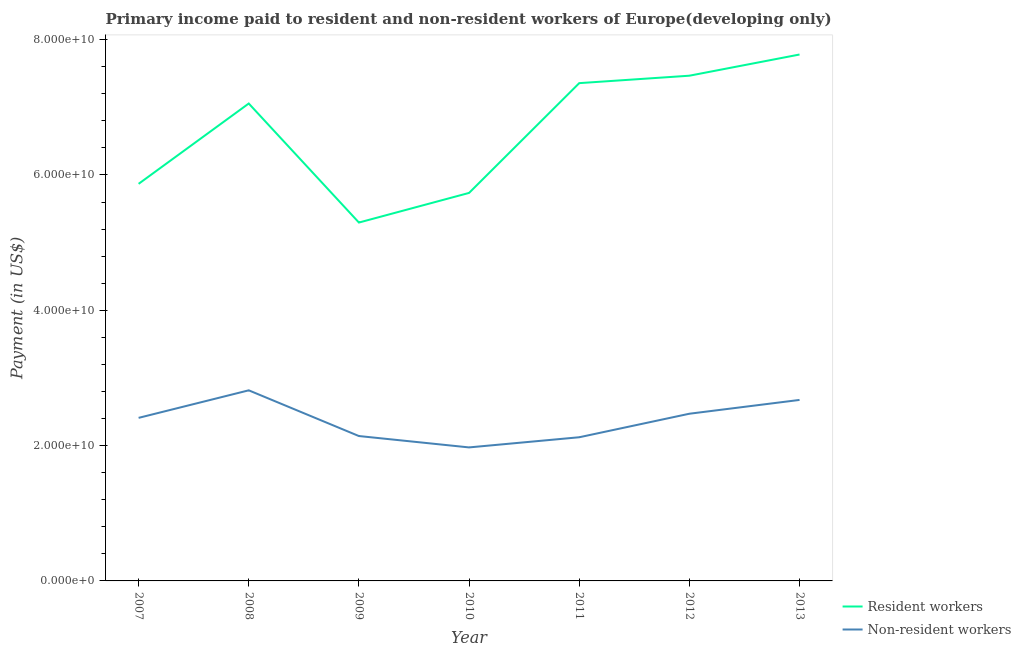How many different coloured lines are there?
Provide a succinct answer. 2. Is the number of lines equal to the number of legend labels?
Make the answer very short. Yes. What is the payment made to non-resident workers in 2007?
Offer a terse response. 2.41e+1. Across all years, what is the maximum payment made to resident workers?
Ensure brevity in your answer.  7.78e+1. Across all years, what is the minimum payment made to non-resident workers?
Your response must be concise. 1.97e+1. What is the total payment made to non-resident workers in the graph?
Keep it short and to the point. 1.66e+11. What is the difference between the payment made to resident workers in 2008 and that in 2010?
Offer a very short reply. 1.32e+1. What is the difference between the payment made to non-resident workers in 2011 and the payment made to resident workers in 2008?
Your answer should be very brief. -4.93e+1. What is the average payment made to resident workers per year?
Your response must be concise. 6.65e+1. In the year 2010, what is the difference between the payment made to non-resident workers and payment made to resident workers?
Provide a succinct answer. -3.76e+1. In how many years, is the payment made to non-resident workers greater than 60000000000 US$?
Keep it short and to the point. 0. What is the ratio of the payment made to resident workers in 2009 to that in 2011?
Offer a terse response. 0.72. Is the difference between the payment made to resident workers in 2011 and 2013 greater than the difference between the payment made to non-resident workers in 2011 and 2013?
Give a very brief answer. Yes. What is the difference between the highest and the second highest payment made to resident workers?
Make the answer very short. 3.13e+09. What is the difference between the highest and the lowest payment made to non-resident workers?
Provide a short and direct response. 8.44e+09. Is the sum of the payment made to resident workers in 2007 and 2011 greater than the maximum payment made to non-resident workers across all years?
Give a very brief answer. Yes. Does the payment made to non-resident workers monotonically increase over the years?
Your response must be concise. No. Is the payment made to non-resident workers strictly greater than the payment made to resident workers over the years?
Your answer should be very brief. No. How many lines are there?
Offer a terse response. 2. How many years are there in the graph?
Your answer should be compact. 7. Does the graph contain any zero values?
Your answer should be very brief. No. Does the graph contain grids?
Give a very brief answer. No. How many legend labels are there?
Keep it short and to the point. 2. How are the legend labels stacked?
Make the answer very short. Vertical. What is the title of the graph?
Your answer should be very brief. Primary income paid to resident and non-resident workers of Europe(developing only). Does "Depositors" appear as one of the legend labels in the graph?
Your response must be concise. No. What is the label or title of the X-axis?
Provide a short and direct response. Year. What is the label or title of the Y-axis?
Offer a terse response. Payment (in US$). What is the Payment (in US$) of Resident workers in 2007?
Your answer should be very brief. 5.87e+1. What is the Payment (in US$) in Non-resident workers in 2007?
Provide a short and direct response. 2.41e+1. What is the Payment (in US$) of Resident workers in 2008?
Your response must be concise. 7.06e+1. What is the Payment (in US$) in Non-resident workers in 2008?
Your answer should be compact. 2.82e+1. What is the Payment (in US$) of Resident workers in 2009?
Offer a very short reply. 5.30e+1. What is the Payment (in US$) of Non-resident workers in 2009?
Your answer should be very brief. 2.14e+1. What is the Payment (in US$) in Resident workers in 2010?
Your answer should be compact. 5.74e+1. What is the Payment (in US$) in Non-resident workers in 2010?
Keep it short and to the point. 1.97e+1. What is the Payment (in US$) in Resident workers in 2011?
Offer a very short reply. 7.36e+1. What is the Payment (in US$) of Non-resident workers in 2011?
Offer a terse response. 2.12e+1. What is the Payment (in US$) of Resident workers in 2012?
Offer a terse response. 7.47e+1. What is the Payment (in US$) of Non-resident workers in 2012?
Make the answer very short. 2.47e+1. What is the Payment (in US$) of Resident workers in 2013?
Provide a succinct answer. 7.78e+1. What is the Payment (in US$) in Non-resident workers in 2013?
Keep it short and to the point. 2.68e+1. Across all years, what is the maximum Payment (in US$) in Resident workers?
Make the answer very short. 7.78e+1. Across all years, what is the maximum Payment (in US$) in Non-resident workers?
Ensure brevity in your answer.  2.82e+1. Across all years, what is the minimum Payment (in US$) of Resident workers?
Ensure brevity in your answer.  5.30e+1. Across all years, what is the minimum Payment (in US$) in Non-resident workers?
Keep it short and to the point. 1.97e+1. What is the total Payment (in US$) of Resident workers in the graph?
Your response must be concise. 4.66e+11. What is the total Payment (in US$) of Non-resident workers in the graph?
Ensure brevity in your answer.  1.66e+11. What is the difference between the Payment (in US$) of Resident workers in 2007 and that in 2008?
Keep it short and to the point. -1.19e+1. What is the difference between the Payment (in US$) in Non-resident workers in 2007 and that in 2008?
Ensure brevity in your answer.  -4.07e+09. What is the difference between the Payment (in US$) of Resident workers in 2007 and that in 2009?
Keep it short and to the point. 5.72e+09. What is the difference between the Payment (in US$) of Non-resident workers in 2007 and that in 2009?
Provide a succinct answer. 2.69e+09. What is the difference between the Payment (in US$) in Resident workers in 2007 and that in 2010?
Give a very brief answer. 1.34e+09. What is the difference between the Payment (in US$) of Non-resident workers in 2007 and that in 2010?
Your answer should be very brief. 4.37e+09. What is the difference between the Payment (in US$) of Resident workers in 2007 and that in 2011?
Your answer should be compact. -1.49e+1. What is the difference between the Payment (in US$) in Non-resident workers in 2007 and that in 2011?
Give a very brief answer. 2.87e+09. What is the difference between the Payment (in US$) in Resident workers in 2007 and that in 2012?
Provide a short and direct response. -1.60e+1. What is the difference between the Payment (in US$) of Non-resident workers in 2007 and that in 2012?
Give a very brief answer. -6.12e+08. What is the difference between the Payment (in US$) of Resident workers in 2007 and that in 2013?
Your answer should be compact. -1.91e+1. What is the difference between the Payment (in US$) in Non-resident workers in 2007 and that in 2013?
Offer a terse response. -2.65e+09. What is the difference between the Payment (in US$) in Resident workers in 2008 and that in 2009?
Provide a short and direct response. 1.76e+1. What is the difference between the Payment (in US$) of Non-resident workers in 2008 and that in 2009?
Provide a succinct answer. 6.76e+09. What is the difference between the Payment (in US$) of Resident workers in 2008 and that in 2010?
Give a very brief answer. 1.32e+1. What is the difference between the Payment (in US$) of Non-resident workers in 2008 and that in 2010?
Provide a succinct answer. 8.44e+09. What is the difference between the Payment (in US$) of Resident workers in 2008 and that in 2011?
Your answer should be very brief. -3.01e+09. What is the difference between the Payment (in US$) of Non-resident workers in 2008 and that in 2011?
Provide a short and direct response. 6.94e+09. What is the difference between the Payment (in US$) in Resident workers in 2008 and that in 2012?
Your response must be concise. -4.11e+09. What is the difference between the Payment (in US$) of Non-resident workers in 2008 and that in 2012?
Offer a terse response. 3.46e+09. What is the difference between the Payment (in US$) in Resident workers in 2008 and that in 2013?
Keep it short and to the point. -7.24e+09. What is the difference between the Payment (in US$) in Non-resident workers in 2008 and that in 2013?
Provide a succinct answer. 1.42e+09. What is the difference between the Payment (in US$) of Resident workers in 2009 and that in 2010?
Ensure brevity in your answer.  -4.38e+09. What is the difference between the Payment (in US$) of Non-resident workers in 2009 and that in 2010?
Keep it short and to the point. 1.68e+09. What is the difference between the Payment (in US$) of Resident workers in 2009 and that in 2011?
Offer a very short reply. -2.06e+1. What is the difference between the Payment (in US$) in Non-resident workers in 2009 and that in 2011?
Your answer should be very brief. 1.79e+08. What is the difference between the Payment (in US$) of Resident workers in 2009 and that in 2012?
Keep it short and to the point. -2.17e+1. What is the difference between the Payment (in US$) of Non-resident workers in 2009 and that in 2012?
Your answer should be compact. -3.30e+09. What is the difference between the Payment (in US$) of Resident workers in 2009 and that in 2013?
Offer a very short reply. -2.48e+1. What is the difference between the Payment (in US$) of Non-resident workers in 2009 and that in 2013?
Provide a succinct answer. -5.34e+09. What is the difference between the Payment (in US$) in Resident workers in 2010 and that in 2011?
Ensure brevity in your answer.  -1.62e+1. What is the difference between the Payment (in US$) in Non-resident workers in 2010 and that in 2011?
Provide a succinct answer. -1.50e+09. What is the difference between the Payment (in US$) in Resident workers in 2010 and that in 2012?
Your answer should be compact. -1.73e+1. What is the difference between the Payment (in US$) in Non-resident workers in 2010 and that in 2012?
Give a very brief answer. -4.98e+09. What is the difference between the Payment (in US$) in Resident workers in 2010 and that in 2013?
Your answer should be very brief. -2.05e+1. What is the difference between the Payment (in US$) in Non-resident workers in 2010 and that in 2013?
Your response must be concise. -7.02e+09. What is the difference between the Payment (in US$) of Resident workers in 2011 and that in 2012?
Offer a terse response. -1.10e+09. What is the difference between the Payment (in US$) of Non-resident workers in 2011 and that in 2012?
Offer a terse response. -3.48e+09. What is the difference between the Payment (in US$) in Resident workers in 2011 and that in 2013?
Your answer should be very brief. -4.23e+09. What is the difference between the Payment (in US$) in Non-resident workers in 2011 and that in 2013?
Provide a succinct answer. -5.52e+09. What is the difference between the Payment (in US$) in Resident workers in 2012 and that in 2013?
Your response must be concise. -3.13e+09. What is the difference between the Payment (in US$) of Non-resident workers in 2012 and that in 2013?
Keep it short and to the point. -2.04e+09. What is the difference between the Payment (in US$) in Resident workers in 2007 and the Payment (in US$) in Non-resident workers in 2008?
Provide a short and direct response. 3.05e+1. What is the difference between the Payment (in US$) of Resident workers in 2007 and the Payment (in US$) of Non-resident workers in 2009?
Your answer should be very brief. 3.73e+1. What is the difference between the Payment (in US$) in Resident workers in 2007 and the Payment (in US$) in Non-resident workers in 2010?
Make the answer very short. 3.90e+1. What is the difference between the Payment (in US$) in Resident workers in 2007 and the Payment (in US$) in Non-resident workers in 2011?
Make the answer very short. 3.75e+1. What is the difference between the Payment (in US$) of Resident workers in 2007 and the Payment (in US$) of Non-resident workers in 2012?
Ensure brevity in your answer.  3.40e+1. What is the difference between the Payment (in US$) of Resident workers in 2007 and the Payment (in US$) of Non-resident workers in 2013?
Provide a succinct answer. 3.19e+1. What is the difference between the Payment (in US$) in Resident workers in 2008 and the Payment (in US$) in Non-resident workers in 2009?
Make the answer very short. 4.92e+1. What is the difference between the Payment (in US$) of Resident workers in 2008 and the Payment (in US$) of Non-resident workers in 2010?
Offer a terse response. 5.08e+1. What is the difference between the Payment (in US$) in Resident workers in 2008 and the Payment (in US$) in Non-resident workers in 2011?
Provide a succinct answer. 4.93e+1. What is the difference between the Payment (in US$) in Resident workers in 2008 and the Payment (in US$) in Non-resident workers in 2012?
Provide a succinct answer. 4.59e+1. What is the difference between the Payment (in US$) in Resident workers in 2008 and the Payment (in US$) in Non-resident workers in 2013?
Offer a terse response. 4.38e+1. What is the difference between the Payment (in US$) in Resident workers in 2009 and the Payment (in US$) in Non-resident workers in 2010?
Ensure brevity in your answer.  3.32e+1. What is the difference between the Payment (in US$) in Resident workers in 2009 and the Payment (in US$) in Non-resident workers in 2011?
Ensure brevity in your answer.  3.17e+1. What is the difference between the Payment (in US$) of Resident workers in 2009 and the Payment (in US$) of Non-resident workers in 2012?
Your response must be concise. 2.83e+1. What is the difference between the Payment (in US$) in Resident workers in 2009 and the Payment (in US$) in Non-resident workers in 2013?
Offer a terse response. 2.62e+1. What is the difference between the Payment (in US$) of Resident workers in 2010 and the Payment (in US$) of Non-resident workers in 2011?
Give a very brief answer. 3.61e+1. What is the difference between the Payment (in US$) of Resident workers in 2010 and the Payment (in US$) of Non-resident workers in 2012?
Your answer should be very brief. 3.26e+1. What is the difference between the Payment (in US$) of Resident workers in 2010 and the Payment (in US$) of Non-resident workers in 2013?
Provide a succinct answer. 3.06e+1. What is the difference between the Payment (in US$) in Resident workers in 2011 and the Payment (in US$) in Non-resident workers in 2012?
Provide a succinct answer. 4.89e+1. What is the difference between the Payment (in US$) of Resident workers in 2011 and the Payment (in US$) of Non-resident workers in 2013?
Your answer should be compact. 4.68e+1. What is the difference between the Payment (in US$) of Resident workers in 2012 and the Payment (in US$) of Non-resident workers in 2013?
Make the answer very short. 4.79e+1. What is the average Payment (in US$) in Resident workers per year?
Provide a succinct answer. 6.65e+1. What is the average Payment (in US$) in Non-resident workers per year?
Ensure brevity in your answer.  2.37e+1. In the year 2007, what is the difference between the Payment (in US$) in Resident workers and Payment (in US$) in Non-resident workers?
Keep it short and to the point. 3.46e+1. In the year 2008, what is the difference between the Payment (in US$) in Resident workers and Payment (in US$) in Non-resident workers?
Provide a short and direct response. 4.24e+1. In the year 2009, what is the difference between the Payment (in US$) in Resident workers and Payment (in US$) in Non-resident workers?
Provide a short and direct response. 3.16e+1. In the year 2010, what is the difference between the Payment (in US$) of Resident workers and Payment (in US$) of Non-resident workers?
Provide a short and direct response. 3.76e+1. In the year 2011, what is the difference between the Payment (in US$) in Resident workers and Payment (in US$) in Non-resident workers?
Give a very brief answer. 5.23e+1. In the year 2012, what is the difference between the Payment (in US$) of Resident workers and Payment (in US$) of Non-resident workers?
Keep it short and to the point. 5.00e+1. In the year 2013, what is the difference between the Payment (in US$) of Resident workers and Payment (in US$) of Non-resident workers?
Offer a terse response. 5.11e+1. What is the ratio of the Payment (in US$) in Resident workers in 2007 to that in 2008?
Your answer should be compact. 0.83. What is the ratio of the Payment (in US$) in Non-resident workers in 2007 to that in 2008?
Keep it short and to the point. 0.86. What is the ratio of the Payment (in US$) in Resident workers in 2007 to that in 2009?
Give a very brief answer. 1.11. What is the ratio of the Payment (in US$) in Non-resident workers in 2007 to that in 2009?
Provide a succinct answer. 1.13. What is the ratio of the Payment (in US$) in Resident workers in 2007 to that in 2010?
Your answer should be compact. 1.02. What is the ratio of the Payment (in US$) of Non-resident workers in 2007 to that in 2010?
Your response must be concise. 1.22. What is the ratio of the Payment (in US$) of Resident workers in 2007 to that in 2011?
Your response must be concise. 0.8. What is the ratio of the Payment (in US$) in Non-resident workers in 2007 to that in 2011?
Offer a terse response. 1.13. What is the ratio of the Payment (in US$) in Resident workers in 2007 to that in 2012?
Give a very brief answer. 0.79. What is the ratio of the Payment (in US$) in Non-resident workers in 2007 to that in 2012?
Your answer should be very brief. 0.98. What is the ratio of the Payment (in US$) of Resident workers in 2007 to that in 2013?
Provide a short and direct response. 0.75. What is the ratio of the Payment (in US$) in Non-resident workers in 2007 to that in 2013?
Provide a succinct answer. 0.9. What is the ratio of the Payment (in US$) in Resident workers in 2008 to that in 2009?
Give a very brief answer. 1.33. What is the ratio of the Payment (in US$) in Non-resident workers in 2008 to that in 2009?
Offer a very short reply. 1.32. What is the ratio of the Payment (in US$) of Resident workers in 2008 to that in 2010?
Give a very brief answer. 1.23. What is the ratio of the Payment (in US$) in Non-resident workers in 2008 to that in 2010?
Your answer should be very brief. 1.43. What is the ratio of the Payment (in US$) of Resident workers in 2008 to that in 2011?
Offer a very short reply. 0.96. What is the ratio of the Payment (in US$) in Non-resident workers in 2008 to that in 2011?
Make the answer very short. 1.33. What is the ratio of the Payment (in US$) of Resident workers in 2008 to that in 2012?
Make the answer very short. 0.94. What is the ratio of the Payment (in US$) of Non-resident workers in 2008 to that in 2012?
Provide a succinct answer. 1.14. What is the ratio of the Payment (in US$) of Resident workers in 2008 to that in 2013?
Your answer should be very brief. 0.91. What is the ratio of the Payment (in US$) in Non-resident workers in 2008 to that in 2013?
Your answer should be compact. 1.05. What is the ratio of the Payment (in US$) in Resident workers in 2009 to that in 2010?
Ensure brevity in your answer.  0.92. What is the ratio of the Payment (in US$) in Non-resident workers in 2009 to that in 2010?
Ensure brevity in your answer.  1.09. What is the ratio of the Payment (in US$) in Resident workers in 2009 to that in 2011?
Make the answer very short. 0.72. What is the ratio of the Payment (in US$) of Non-resident workers in 2009 to that in 2011?
Keep it short and to the point. 1.01. What is the ratio of the Payment (in US$) in Resident workers in 2009 to that in 2012?
Keep it short and to the point. 0.71. What is the ratio of the Payment (in US$) of Non-resident workers in 2009 to that in 2012?
Ensure brevity in your answer.  0.87. What is the ratio of the Payment (in US$) in Resident workers in 2009 to that in 2013?
Your response must be concise. 0.68. What is the ratio of the Payment (in US$) of Non-resident workers in 2009 to that in 2013?
Give a very brief answer. 0.8. What is the ratio of the Payment (in US$) in Resident workers in 2010 to that in 2011?
Your response must be concise. 0.78. What is the ratio of the Payment (in US$) of Non-resident workers in 2010 to that in 2011?
Make the answer very short. 0.93. What is the ratio of the Payment (in US$) of Resident workers in 2010 to that in 2012?
Provide a succinct answer. 0.77. What is the ratio of the Payment (in US$) of Non-resident workers in 2010 to that in 2012?
Offer a terse response. 0.8. What is the ratio of the Payment (in US$) in Resident workers in 2010 to that in 2013?
Ensure brevity in your answer.  0.74. What is the ratio of the Payment (in US$) in Non-resident workers in 2010 to that in 2013?
Provide a short and direct response. 0.74. What is the ratio of the Payment (in US$) in Non-resident workers in 2011 to that in 2012?
Give a very brief answer. 0.86. What is the ratio of the Payment (in US$) of Resident workers in 2011 to that in 2013?
Offer a very short reply. 0.95. What is the ratio of the Payment (in US$) in Non-resident workers in 2011 to that in 2013?
Make the answer very short. 0.79. What is the ratio of the Payment (in US$) in Resident workers in 2012 to that in 2013?
Provide a succinct answer. 0.96. What is the ratio of the Payment (in US$) of Non-resident workers in 2012 to that in 2013?
Offer a very short reply. 0.92. What is the difference between the highest and the second highest Payment (in US$) of Resident workers?
Provide a succinct answer. 3.13e+09. What is the difference between the highest and the second highest Payment (in US$) in Non-resident workers?
Provide a succinct answer. 1.42e+09. What is the difference between the highest and the lowest Payment (in US$) in Resident workers?
Keep it short and to the point. 2.48e+1. What is the difference between the highest and the lowest Payment (in US$) in Non-resident workers?
Provide a succinct answer. 8.44e+09. 